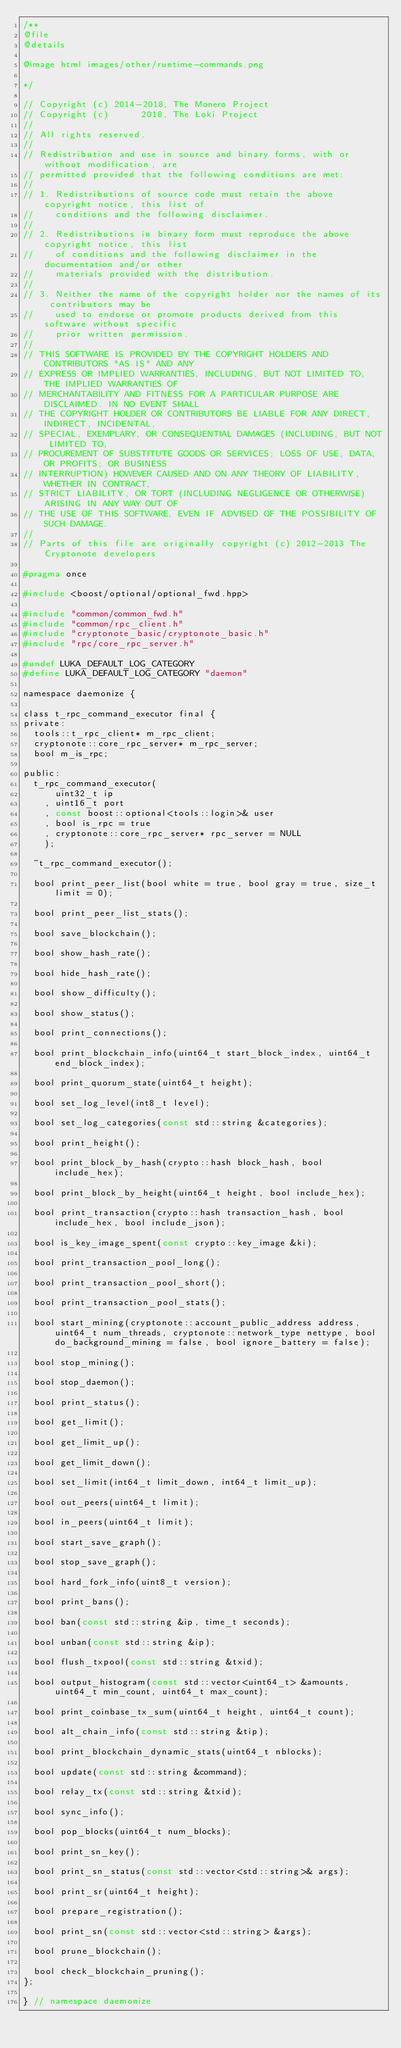Convert code to text. <code><loc_0><loc_0><loc_500><loc_500><_C_>/**
@file
@details

@image html images/other/runtime-commands.png

*/

// Copyright (c) 2014-2018, The Monero Project
// Copyright (c)      2018, The Loki Project
// 
// All rights reserved.
// 
// Redistribution and use in source and binary forms, with or without modification, are
// permitted provided that the following conditions are met:
// 
// 1. Redistributions of source code must retain the above copyright notice, this list of
//    conditions and the following disclaimer.
// 
// 2. Redistributions in binary form must reproduce the above copyright notice, this list
//    of conditions and the following disclaimer in the documentation and/or other
//    materials provided with the distribution.
// 
// 3. Neither the name of the copyright holder nor the names of its contributors may be
//    used to endorse or promote products derived from this software without specific
//    prior written permission.
// 
// THIS SOFTWARE IS PROVIDED BY THE COPYRIGHT HOLDERS AND CONTRIBUTORS "AS IS" AND ANY
// EXPRESS OR IMPLIED WARRANTIES, INCLUDING, BUT NOT LIMITED TO, THE IMPLIED WARRANTIES OF
// MERCHANTABILITY AND FITNESS FOR A PARTICULAR PURPOSE ARE DISCLAIMED. IN NO EVENT SHALL
// THE COPYRIGHT HOLDER OR CONTRIBUTORS BE LIABLE FOR ANY DIRECT, INDIRECT, INCIDENTAL,
// SPECIAL, EXEMPLARY, OR CONSEQUENTIAL DAMAGES (INCLUDING, BUT NOT LIMITED TO,
// PROCUREMENT OF SUBSTITUTE GOODS OR SERVICES; LOSS OF USE, DATA, OR PROFITS; OR BUSINESS
// INTERRUPTION) HOWEVER CAUSED AND ON ANY THEORY OF LIABILITY, WHETHER IN CONTRACT,
// STRICT LIABILITY, OR TORT (INCLUDING NEGLIGENCE OR OTHERWISE) ARISING IN ANY WAY OUT OF
// THE USE OF THIS SOFTWARE, EVEN IF ADVISED OF THE POSSIBILITY OF SUCH DAMAGE.
//
// Parts of this file are originally copyright (c) 2012-2013 The Cryptonote developers

#pragma once

#include <boost/optional/optional_fwd.hpp>

#include "common/common_fwd.h"
#include "common/rpc_client.h"
#include "cryptonote_basic/cryptonote_basic.h"
#include "rpc/core_rpc_server.h"

#undef LUKA_DEFAULT_LOG_CATEGORY
#define LUKA_DEFAULT_LOG_CATEGORY "daemon"

namespace daemonize {

class t_rpc_command_executor final {
private:
  tools::t_rpc_client* m_rpc_client;
  cryptonote::core_rpc_server* m_rpc_server;
  bool m_is_rpc;

public:
  t_rpc_command_executor(
      uint32_t ip
    , uint16_t port
    , const boost::optional<tools::login>& user
    , bool is_rpc = true
    , cryptonote::core_rpc_server* rpc_server = NULL
    );

  ~t_rpc_command_executor();

  bool print_peer_list(bool white = true, bool gray = true, size_t limit = 0);

  bool print_peer_list_stats();

  bool save_blockchain();

  bool show_hash_rate();

  bool hide_hash_rate();

  bool show_difficulty();

  bool show_status();

  bool print_connections();

  bool print_blockchain_info(uint64_t start_block_index, uint64_t end_block_index);

  bool print_quorum_state(uint64_t height);

  bool set_log_level(int8_t level);

  bool set_log_categories(const std::string &categories);

  bool print_height();

  bool print_block_by_hash(crypto::hash block_hash, bool include_hex);

  bool print_block_by_height(uint64_t height, bool include_hex);

  bool print_transaction(crypto::hash transaction_hash, bool include_hex, bool include_json);

  bool is_key_image_spent(const crypto::key_image &ki);

  bool print_transaction_pool_long();

  bool print_transaction_pool_short();

  bool print_transaction_pool_stats();

  bool start_mining(cryptonote::account_public_address address, uint64_t num_threads, cryptonote::network_type nettype, bool do_background_mining = false, bool ignore_battery = false);

  bool stop_mining();

  bool stop_daemon();

  bool print_status();

  bool get_limit();

  bool get_limit_up();

  bool get_limit_down();

  bool set_limit(int64_t limit_down, int64_t limit_up);

  bool out_peers(uint64_t limit);

  bool in_peers(uint64_t limit);

  bool start_save_graph();
  
  bool stop_save_graph();
  
  bool hard_fork_info(uint8_t version);

  bool print_bans();

  bool ban(const std::string &ip, time_t seconds);

  bool unban(const std::string &ip);

  bool flush_txpool(const std::string &txid);

  bool output_histogram(const std::vector<uint64_t> &amounts, uint64_t min_count, uint64_t max_count);

  bool print_coinbase_tx_sum(uint64_t height, uint64_t count);

  bool alt_chain_info(const std::string &tip);

  bool print_blockchain_dynamic_stats(uint64_t nblocks);

  bool update(const std::string &command);

  bool relay_tx(const std::string &txid);

  bool sync_info();

  bool pop_blocks(uint64_t num_blocks);

  bool print_sn_key();

  bool print_sn_status(const std::vector<std::string>& args);

  bool print_sr(uint64_t height);

  bool prepare_registration();

  bool print_sn(const std::vector<std::string> &args);

  bool prune_blockchain();

  bool check_blockchain_pruning();
};

} // namespace daemonize
</code> 